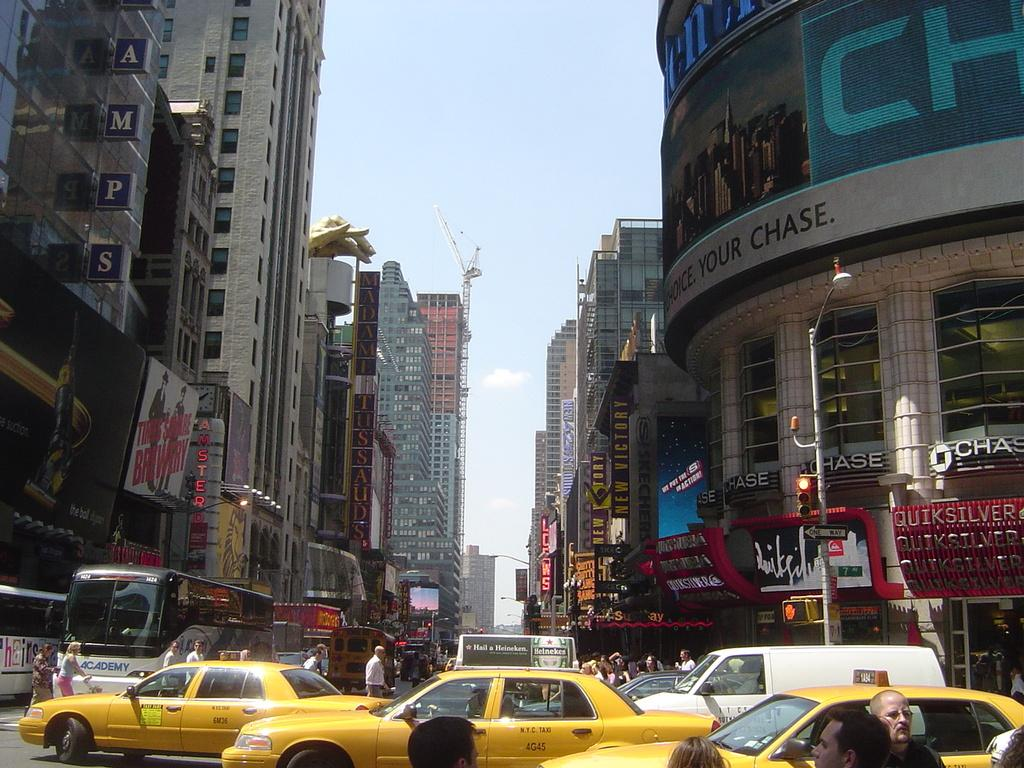<image>
Provide a brief description of the given image. Taxi cabs are driving outside of a Chase bank building. 